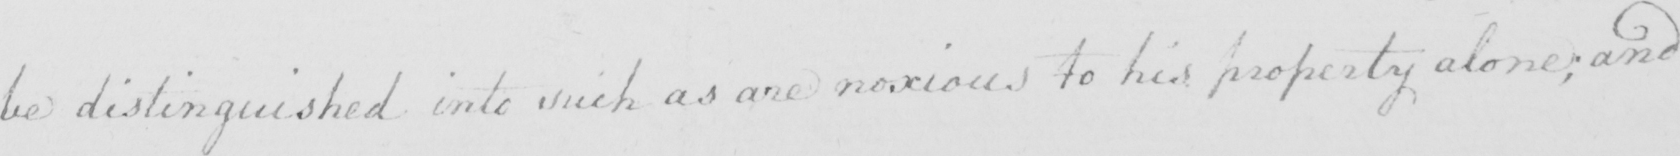Can you tell me what this handwritten text says? be distinguished into such as are noxious to his property alone ; and 